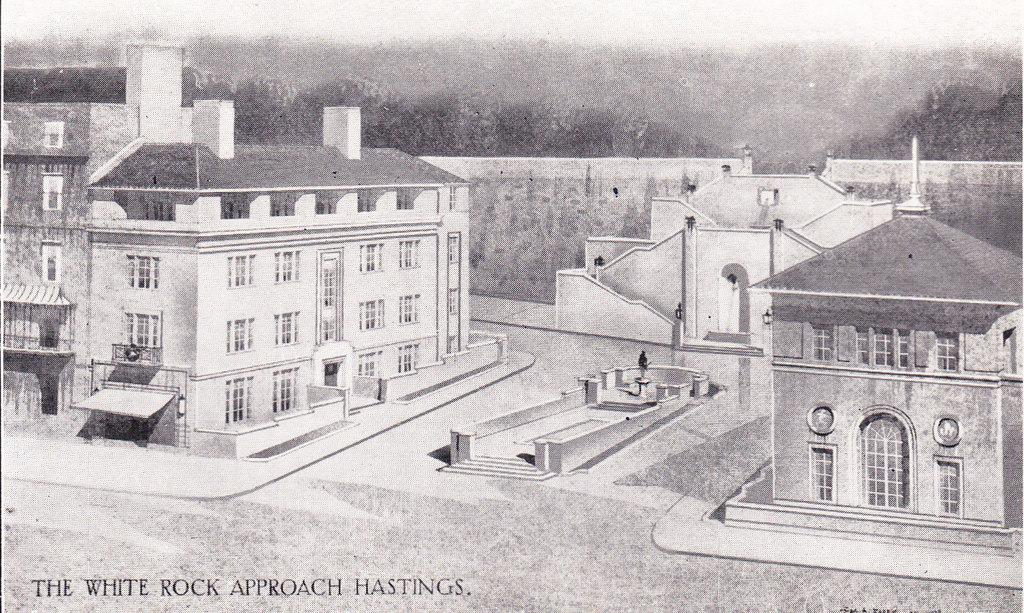What type of structure is visible in the image? There is a building in the image. What part of the building can be seen in the image? There is a window in the image. What architectural feature is present in the image? There is a gate in the image. What type of residential structure is visible in the image? There is a house in the image. What type of barrier is present in the image? There is a wall in the image. What type of natural element is visible in the image? There are trees in the image. What is the color scheme of the image? The image is in black and white. What type of government is depicted in the image? There is no depiction of a government in the image; it features a building, window, gate, house, wall, trees, and is in black and white. What type of battle is taking place in the image? There is no battle depicted in the image; it features a building, window, gate, house, wall, trees, and is in black and white. 